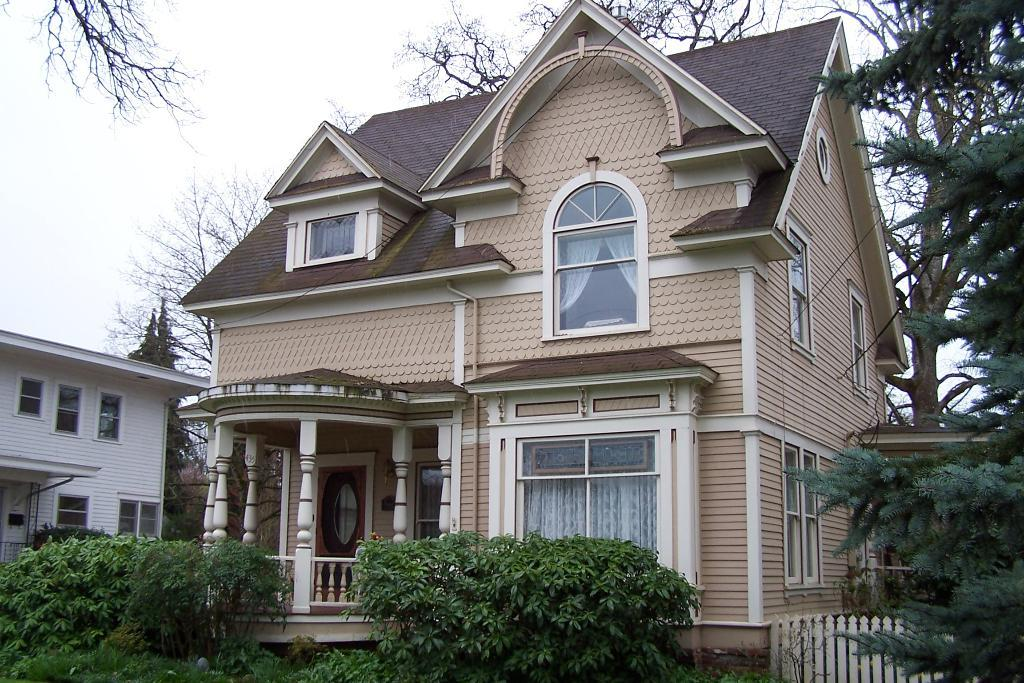How many buildings can be seen in the image? There are two buildings in the image. What is located at the bottom of the image? There are many plants at the bottom of the image. What can be seen on the right side of the image? There is fencing and trees on the right side of the image. What is visible at the top of the image? The sky is visible at the top of the image. What is the value of the plant in the image? There is no specific plant mentioned in the image, and the concept of value does not apply to the plants in this context. 